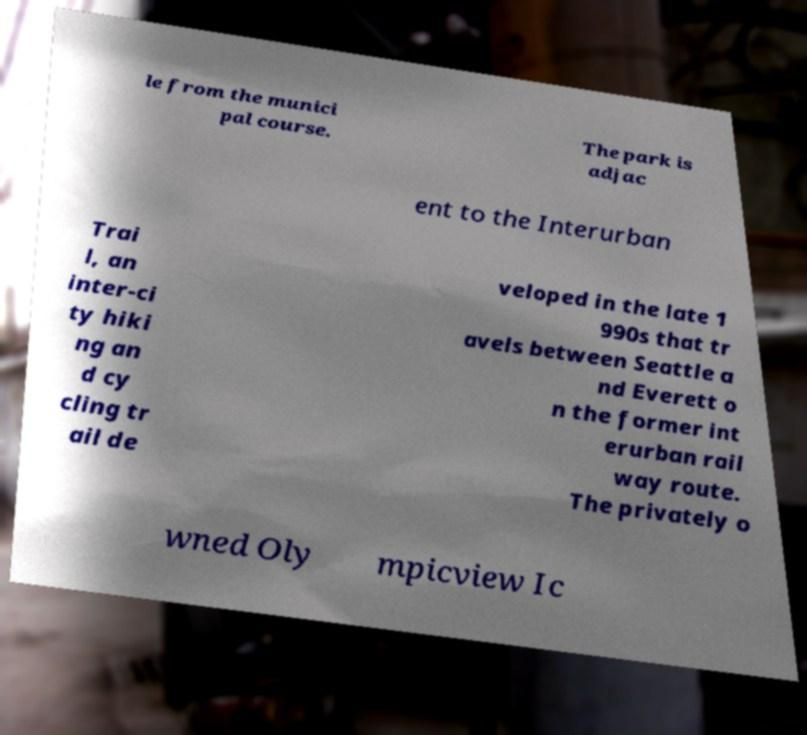Please identify and transcribe the text found in this image. le from the munici pal course. The park is adjac ent to the Interurban Trai l, an inter-ci ty hiki ng an d cy cling tr ail de veloped in the late 1 990s that tr avels between Seattle a nd Everett o n the former int erurban rail way route. The privately o wned Oly mpicview Ic 